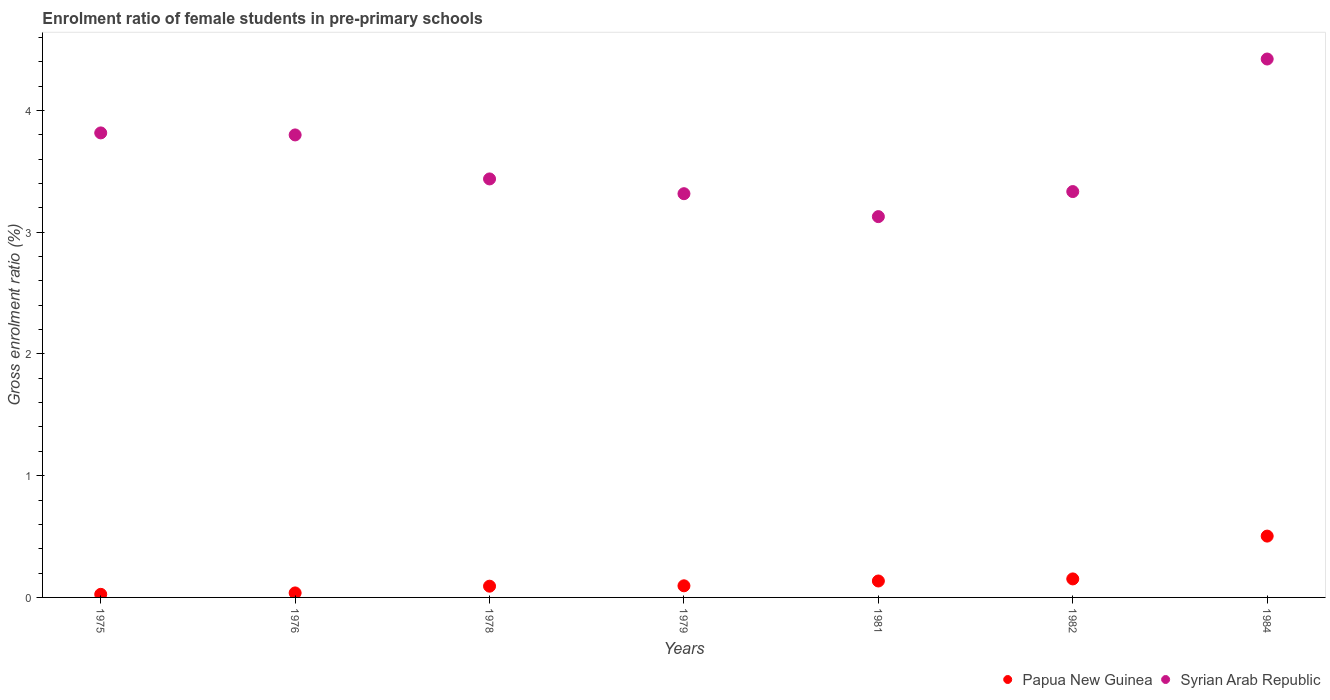How many different coloured dotlines are there?
Your response must be concise. 2. What is the enrolment ratio of female students in pre-primary schools in Syrian Arab Republic in 1982?
Your answer should be very brief. 3.33. Across all years, what is the maximum enrolment ratio of female students in pre-primary schools in Papua New Guinea?
Your answer should be compact. 0.5. Across all years, what is the minimum enrolment ratio of female students in pre-primary schools in Papua New Guinea?
Offer a very short reply. 0.03. In which year was the enrolment ratio of female students in pre-primary schools in Papua New Guinea maximum?
Offer a very short reply. 1984. In which year was the enrolment ratio of female students in pre-primary schools in Papua New Guinea minimum?
Give a very brief answer. 1975. What is the total enrolment ratio of female students in pre-primary schools in Papua New Guinea in the graph?
Provide a short and direct response. 1.04. What is the difference between the enrolment ratio of female students in pre-primary schools in Syrian Arab Republic in 1975 and that in 1982?
Your answer should be compact. 0.48. What is the difference between the enrolment ratio of female students in pre-primary schools in Papua New Guinea in 1984 and the enrolment ratio of female students in pre-primary schools in Syrian Arab Republic in 1975?
Ensure brevity in your answer.  -3.31. What is the average enrolment ratio of female students in pre-primary schools in Syrian Arab Republic per year?
Your answer should be very brief. 3.61. In the year 1978, what is the difference between the enrolment ratio of female students in pre-primary schools in Syrian Arab Republic and enrolment ratio of female students in pre-primary schools in Papua New Guinea?
Give a very brief answer. 3.35. In how many years, is the enrolment ratio of female students in pre-primary schools in Papua New Guinea greater than 1 %?
Your answer should be compact. 0. What is the ratio of the enrolment ratio of female students in pre-primary schools in Syrian Arab Republic in 1975 to that in 1981?
Keep it short and to the point. 1.22. Is the enrolment ratio of female students in pre-primary schools in Papua New Guinea in 1978 less than that in 1982?
Provide a short and direct response. Yes. What is the difference between the highest and the second highest enrolment ratio of female students in pre-primary schools in Papua New Guinea?
Make the answer very short. 0.35. What is the difference between the highest and the lowest enrolment ratio of female students in pre-primary schools in Papua New Guinea?
Provide a short and direct response. 0.48. In how many years, is the enrolment ratio of female students in pre-primary schools in Syrian Arab Republic greater than the average enrolment ratio of female students in pre-primary schools in Syrian Arab Republic taken over all years?
Your answer should be very brief. 3. Is the sum of the enrolment ratio of female students in pre-primary schools in Papua New Guinea in 1975 and 1978 greater than the maximum enrolment ratio of female students in pre-primary schools in Syrian Arab Republic across all years?
Provide a short and direct response. No. Is the enrolment ratio of female students in pre-primary schools in Syrian Arab Republic strictly greater than the enrolment ratio of female students in pre-primary schools in Papua New Guinea over the years?
Your answer should be compact. Yes. Is the enrolment ratio of female students in pre-primary schools in Papua New Guinea strictly less than the enrolment ratio of female students in pre-primary schools in Syrian Arab Republic over the years?
Provide a short and direct response. Yes. How many dotlines are there?
Provide a short and direct response. 2. Does the graph contain grids?
Provide a succinct answer. No. How many legend labels are there?
Make the answer very short. 2. What is the title of the graph?
Keep it short and to the point. Enrolment ratio of female students in pre-primary schools. What is the label or title of the X-axis?
Make the answer very short. Years. What is the label or title of the Y-axis?
Provide a succinct answer. Gross enrolment ratio (%). What is the Gross enrolment ratio (%) in Papua New Guinea in 1975?
Ensure brevity in your answer.  0.03. What is the Gross enrolment ratio (%) of Syrian Arab Republic in 1975?
Your response must be concise. 3.82. What is the Gross enrolment ratio (%) in Papua New Guinea in 1976?
Offer a terse response. 0.04. What is the Gross enrolment ratio (%) of Syrian Arab Republic in 1976?
Provide a short and direct response. 3.8. What is the Gross enrolment ratio (%) in Papua New Guinea in 1978?
Your response must be concise. 0.09. What is the Gross enrolment ratio (%) of Syrian Arab Republic in 1978?
Keep it short and to the point. 3.44. What is the Gross enrolment ratio (%) in Papua New Guinea in 1979?
Your response must be concise. 0.1. What is the Gross enrolment ratio (%) of Syrian Arab Republic in 1979?
Provide a succinct answer. 3.32. What is the Gross enrolment ratio (%) of Papua New Guinea in 1981?
Ensure brevity in your answer.  0.14. What is the Gross enrolment ratio (%) of Syrian Arab Republic in 1981?
Offer a very short reply. 3.13. What is the Gross enrolment ratio (%) in Papua New Guinea in 1982?
Offer a very short reply. 0.15. What is the Gross enrolment ratio (%) in Syrian Arab Republic in 1982?
Your answer should be compact. 3.33. What is the Gross enrolment ratio (%) of Papua New Guinea in 1984?
Provide a short and direct response. 0.5. What is the Gross enrolment ratio (%) of Syrian Arab Republic in 1984?
Your response must be concise. 4.42. Across all years, what is the maximum Gross enrolment ratio (%) of Papua New Guinea?
Offer a very short reply. 0.5. Across all years, what is the maximum Gross enrolment ratio (%) of Syrian Arab Republic?
Offer a very short reply. 4.42. Across all years, what is the minimum Gross enrolment ratio (%) of Papua New Guinea?
Your answer should be very brief. 0.03. Across all years, what is the minimum Gross enrolment ratio (%) in Syrian Arab Republic?
Provide a succinct answer. 3.13. What is the total Gross enrolment ratio (%) in Papua New Guinea in the graph?
Your answer should be very brief. 1.04. What is the total Gross enrolment ratio (%) in Syrian Arab Republic in the graph?
Provide a short and direct response. 25.25. What is the difference between the Gross enrolment ratio (%) in Papua New Guinea in 1975 and that in 1976?
Provide a succinct answer. -0.01. What is the difference between the Gross enrolment ratio (%) in Syrian Arab Republic in 1975 and that in 1976?
Make the answer very short. 0.02. What is the difference between the Gross enrolment ratio (%) of Papua New Guinea in 1975 and that in 1978?
Offer a very short reply. -0.07. What is the difference between the Gross enrolment ratio (%) in Syrian Arab Republic in 1975 and that in 1978?
Give a very brief answer. 0.38. What is the difference between the Gross enrolment ratio (%) in Papua New Guinea in 1975 and that in 1979?
Provide a short and direct response. -0.07. What is the difference between the Gross enrolment ratio (%) of Syrian Arab Republic in 1975 and that in 1979?
Offer a terse response. 0.5. What is the difference between the Gross enrolment ratio (%) of Papua New Guinea in 1975 and that in 1981?
Offer a terse response. -0.11. What is the difference between the Gross enrolment ratio (%) in Syrian Arab Republic in 1975 and that in 1981?
Provide a short and direct response. 0.69. What is the difference between the Gross enrolment ratio (%) in Papua New Guinea in 1975 and that in 1982?
Provide a succinct answer. -0.13. What is the difference between the Gross enrolment ratio (%) in Syrian Arab Republic in 1975 and that in 1982?
Your response must be concise. 0.48. What is the difference between the Gross enrolment ratio (%) in Papua New Guinea in 1975 and that in 1984?
Your response must be concise. -0.48. What is the difference between the Gross enrolment ratio (%) of Syrian Arab Republic in 1975 and that in 1984?
Ensure brevity in your answer.  -0.61. What is the difference between the Gross enrolment ratio (%) in Papua New Guinea in 1976 and that in 1978?
Provide a short and direct response. -0.06. What is the difference between the Gross enrolment ratio (%) of Syrian Arab Republic in 1976 and that in 1978?
Provide a succinct answer. 0.36. What is the difference between the Gross enrolment ratio (%) in Papua New Guinea in 1976 and that in 1979?
Ensure brevity in your answer.  -0.06. What is the difference between the Gross enrolment ratio (%) in Syrian Arab Republic in 1976 and that in 1979?
Make the answer very short. 0.48. What is the difference between the Gross enrolment ratio (%) of Papua New Guinea in 1976 and that in 1981?
Ensure brevity in your answer.  -0.1. What is the difference between the Gross enrolment ratio (%) of Syrian Arab Republic in 1976 and that in 1981?
Keep it short and to the point. 0.67. What is the difference between the Gross enrolment ratio (%) of Papua New Guinea in 1976 and that in 1982?
Offer a very short reply. -0.12. What is the difference between the Gross enrolment ratio (%) in Syrian Arab Republic in 1976 and that in 1982?
Keep it short and to the point. 0.47. What is the difference between the Gross enrolment ratio (%) of Papua New Guinea in 1976 and that in 1984?
Your response must be concise. -0.47. What is the difference between the Gross enrolment ratio (%) of Syrian Arab Republic in 1976 and that in 1984?
Provide a succinct answer. -0.62. What is the difference between the Gross enrolment ratio (%) in Papua New Guinea in 1978 and that in 1979?
Your answer should be very brief. -0. What is the difference between the Gross enrolment ratio (%) in Syrian Arab Republic in 1978 and that in 1979?
Ensure brevity in your answer.  0.12. What is the difference between the Gross enrolment ratio (%) of Papua New Guinea in 1978 and that in 1981?
Make the answer very short. -0.04. What is the difference between the Gross enrolment ratio (%) of Syrian Arab Republic in 1978 and that in 1981?
Provide a succinct answer. 0.31. What is the difference between the Gross enrolment ratio (%) of Papua New Guinea in 1978 and that in 1982?
Your answer should be very brief. -0.06. What is the difference between the Gross enrolment ratio (%) of Syrian Arab Republic in 1978 and that in 1982?
Ensure brevity in your answer.  0.1. What is the difference between the Gross enrolment ratio (%) in Papua New Guinea in 1978 and that in 1984?
Keep it short and to the point. -0.41. What is the difference between the Gross enrolment ratio (%) of Syrian Arab Republic in 1978 and that in 1984?
Your answer should be very brief. -0.98. What is the difference between the Gross enrolment ratio (%) of Papua New Guinea in 1979 and that in 1981?
Give a very brief answer. -0.04. What is the difference between the Gross enrolment ratio (%) of Syrian Arab Republic in 1979 and that in 1981?
Give a very brief answer. 0.19. What is the difference between the Gross enrolment ratio (%) in Papua New Guinea in 1979 and that in 1982?
Give a very brief answer. -0.06. What is the difference between the Gross enrolment ratio (%) of Syrian Arab Republic in 1979 and that in 1982?
Offer a terse response. -0.02. What is the difference between the Gross enrolment ratio (%) of Papua New Guinea in 1979 and that in 1984?
Your answer should be very brief. -0.41. What is the difference between the Gross enrolment ratio (%) of Syrian Arab Republic in 1979 and that in 1984?
Give a very brief answer. -1.11. What is the difference between the Gross enrolment ratio (%) in Papua New Guinea in 1981 and that in 1982?
Keep it short and to the point. -0.02. What is the difference between the Gross enrolment ratio (%) in Syrian Arab Republic in 1981 and that in 1982?
Your response must be concise. -0.21. What is the difference between the Gross enrolment ratio (%) of Papua New Guinea in 1981 and that in 1984?
Offer a very short reply. -0.37. What is the difference between the Gross enrolment ratio (%) in Syrian Arab Republic in 1981 and that in 1984?
Your answer should be compact. -1.29. What is the difference between the Gross enrolment ratio (%) in Papua New Guinea in 1982 and that in 1984?
Ensure brevity in your answer.  -0.35. What is the difference between the Gross enrolment ratio (%) of Syrian Arab Republic in 1982 and that in 1984?
Provide a short and direct response. -1.09. What is the difference between the Gross enrolment ratio (%) of Papua New Guinea in 1975 and the Gross enrolment ratio (%) of Syrian Arab Republic in 1976?
Ensure brevity in your answer.  -3.77. What is the difference between the Gross enrolment ratio (%) in Papua New Guinea in 1975 and the Gross enrolment ratio (%) in Syrian Arab Republic in 1978?
Offer a very short reply. -3.41. What is the difference between the Gross enrolment ratio (%) in Papua New Guinea in 1975 and the Gross enrolment ratio (%) in Syrian Arab Republic in 1979?
Offer a very short reply. -3.29. What is the difference between the Gross enrolment ratio (%) in Papua New Guinea in 1975 and the Gross enrolment ratio (%) in Syrian Arab Republic in 1981?
Provide a succinct answer. -3.1. What is the difference between the Gross enrolment ratio (%) of Papua New Guinea in 1975 and the Gross enrolment ratio (%) of Syrian Arab Republic in 1982?
Provide a succinct answer. -3.31. What is the difference between the Gross enrolment ratio (%) of Papua New Guinea in 1975 and the Gross enrolment ratio (%) of Syrian Arab Republic in 1984?
Offer a terse response. -4.4. What is the difference between the Gross enrolment ratio (%) in Papua New Guinea in 1976 and the Gross enrolment ratio (%) in Syrian Arab Republic in 1978?
Provide a short and direct response. -3.4. What is the difference between the Gross enrolment ratio (%) of Papua New Guinea in 1976 and the Gross enrolment ratio (%) of Syrian Arab Republic in 1979?
Your answer should be very brief. -3.28. What is the difference between the Gross enrolment ratio (%) of Papua New Guinea in 1976 and the Gross enrolment ratio (%) of Syrian Arab Republic in 1981?
Give a very brief answer. -3.09. What is the difference between the Gross enrolment ratio (%) of Papua New Guinea in 1976 and the Gross enrolment ratio (%) of Syrian Arab Republic in 1982?
Your answer should be very brief. -3.3. What is the difference between the Gross enrolment ratio (%) of Papua New Guinea in 1976 and the Gross enrolment ratio (%) of Syrian Arab Republic in 1984?
Offer a very short reply. -4.39. What is the difference between the Gross enrolment ratio (%) in Papua New Guinea in 1978 and the Gross enrolment ratio (%) in Syrian Arab Republic in 1979?
Offer a terse response. -3.22. What is the difference between the Gross enrolment ratio (%) of Papua New Guinea in 1978 and the Gross enrolment ratio (%) of Syrian Arab Republic in 1981?
Provide a short and direct response. -3.04. What is the difference between the Gross enrolment ratio (%) of Papua New Guinea in 1978 and the Gross enrolment ratio (%) of Syrian Arab Republic in 1982?
Provide a short and direct response. -3.24. What is the difference between the Gross enrolment ratio (%) of Papua New Guinea in 1978 and the Gross enrolment ratio (%) of Syrian Arab Republic in 1984?
Keep it short and to the point. -4.33. What is the difference between the Gross enrolment ratio (%) of Papua New Guinea in 1979 and the Gross enrolment ratio (%) of Syrian Arab Republic in 1981?
Provide a succinct answer. -3.03. What is the difference between the Gross enrolment ratio (%) in Papua New Guinea in 1979 and the Gross enrolment ratio (%) in Syrian Arab Republic in 1982?
Your answer should be very brief. -3.24. What is the difference between the Gross enrolment ratio (%) in Papua New Guinea in 1979 and the Gross enrolment ratio (%) in Syrian Arab Republic in 1984?
Provide a succinct answer. -4.33. What is the difference between the Gross enrolment ratio (%) of Papua New Guinea in 1981 and the Gross enrolment ratio (%) of Syrian Arab Republic in 1982?
Offer a terse response. -3.2. What is the difference between the Gross enrolment ratio (%) in Papua New Guinea in 1981 and the Gross enrolment ratio (%) in Syrian Arab Republic in 1984?
Give a very brief answer. -4.29. What is the difference between the Gross enrolment ratio (%) of Papua New Guinea in 1982 and the Gross enrolment ratio (%) of Syrian Arab Republic in 1984?
Ensure brevity in your answer.  -4.27. What is the average Gross enrolment ratio (%) in Papua New Guinea per year?
Make the answer very short. 0.15. What is the average Gross enrolment ratio (%) in Syrian Arab Republic per year?
Give a very brief answer. 3.61. In the year 1975, what is the difference between the Gross enrolment ratio (%) of Papua New Guinea and Gross enrolment ratio (%) of Syrian Arab Republic?
Your answer should be compact. -3.79. In the year 1976, what is the difference between the Gross enrolment ratio (%) of Papua New Guinea and Gross enrolment ratio (%) of Syrian Arab Republic?
Your response must be concise. -3.76. In the year 1978, what is the difference between the Gross enrolment ratio (%) of Papua New Guinea and Gross enrolment ratio (%) of Syrian Arab Republic?
Ensure brevity in your answer.  -3.35. In the year 1979, what is the difference between the Gross enrolment ratio (%) in Papua New Guinea and Gross enrolment ratio (%) in Syrian Arab Republic?
Make the answer very short. -3.22. In the year 1981, what is the difference between the Gross enrolment ratio (%) of Papua New Guinea and Gross enrolment ratio (%) of Syrian Arab Republic?
Your response must be concise. -2.99. In the year 1982, what is the difference between the Gross enrolment ratio (%) in Papua New Guinea and Gross enrolment ratio (%) in Syrian Arab Republic?
Offer a very short reply. -3.18. In the year 1984, what is the difference between the Gross enrolment ratio (%) of Papua New Guinea and Gross enrolment ratio (%) of Syrian Arab Republic?
Your answer should be very brief. -3.92. What is the ratio of the Gross enrolment ratio (%) in Papua New Guinea in 1975 to that in 1976?
Provide a short and direct response. 0.69. What is the ratio of the Gross enrolment ratio (%) in Papua New Guinea in 1975 to that in 1978?
Your answer should be very brief. 0.28. What is the ratio of the Gross enrolment ratio (%) of Syrian Arab Republic in 1975 to that in 1978?
Ensure brevity in your answer.  1.11. What is the ratio of the Gross enrolment ratio (%) in Papua New Guinea in 1975 to that in 1979?
Offer a terse response. 0.27. What is the ratio of the Gross enrolment ratio (%) of Syrian Arab Republic in 1975 to that in 1979?
Offer a very short reply. 1.15. What is the ratio of the Gross enrolment ratio (%) in Papua New Guinea in 1975 to that in 1981?
Ensure brevity in your answer.  0.19. What is the ratio of the Gross enrolment ratio (%) of Syrian Arab Republic in 1975 to that in 1981?
Your response must be concise. 1.22. What is the ratio of the Gross enrolment ratio (%) in Papua New Guinea in 1975 to that in 1982?
Give a very brief answer. 0.17. What is the ratio of the Gross enrolment ratio (%) of Syrian Arab Republic in 1975 to that in 1982?
Make the answer very short. 1.14. What is the ratio of the Gross enrolment ratio (%) of Papua New Guinea in 1975 to that in 1984?
Offer a very short reply. 0.05. What is the ratio of the Gross enrolment ratio (%) of Syrian Arab Republic in 1975 to that in 1984?
Provide a short and direct response. 0.86. What is the ratio of the Gross enrolment ratio (%) of Papua New Guinea in 1976 to that in 1978?
Offer a very short reply. 0.4. What is the ratio of the Gross enrolment ratio (%) of Syrian Arab Republic in 1976 to that in 1978?
Provide a short and direct response. 1.11. What is the ratio of the Gross enrolment ratio (%) in Papua New Guinea in 1976 to that in 1979?
Provide a short and direct response. 0.39. What is the ratio of the Gross enrolment ratio (%) of Syrian Arab Republic in 1976 to that in 1979?
Your response must be concise. 1.15. What is the ratio of the Gross enrolment ratio (%) in Papua New Guinea in 1976 to that in 1981?
Provide a succinct answer. 0.27. What is the ratio of the Gross enrolment ratio (%) of Syrian Arab Republic in 1976 to that in 1981?
Your answer should be very brief. 1.21. What is the ratio of the Gross enrolment ratio (%) in Papua New Guinea in 1976 to that in 1982?
Make the answer very short. 0.24. What is the ratio of the Gross enrolment ratio (%) of Syrian Arab Republic in 1976 to that in 1982?
Your answer should be compact. 1.14. What is the ratio of the Gross enrolment ratio (%) in Papua New Guinea in 1976 to that in 1984?
Provide a short and direct response. 0.07. What is the ratio of the Gross enrolment ratio (%) in Syrian Arab Republic in 1976 to that in 1984?
Offer a very short reply. 0.86. What is the ratio of the Gross enrolment ratio (%) of Papua New Guinea in 1978 to that in 1979?
Keep it short and to the point. 0.97. What is the ratio of the Gross enrolment ratio (%) of Syrian Arab Republic in 1978 to that in 1979?
Your response must be concise. 1.04. What is the ratio of the Gross enrolment ratio (%) of Papua New Guinea in 1978 to that in 1981?
Provide a short and direct response. 0.68. What is the ratio of the Gross enrolment ratio (%) in Syrian Arab Republic in 1978 to that in 1981?
Make the answer very short. 1.1. What is the ratio of the Gross enrolment ratio (%) in Papua New Guinea in 1978 to that in 1982?
Offer a very short reply. 0.61. What is the ratio of the Gross enrolment ratio (%) in Syrian Arab Republic in 1978 to that in 1982?
Provide a short and direct response. 1.03. What is the ratio of the Gross enrolment ratio (%) in Papua New Guinea in 1978 to that in 1984?
Ensure brevity in your answer.  0.18. What is the ratio of the Gross enrolment ratio (%) of Syrian Arab Republic in 1978 to that in 1984?
Make the answer very short. 0.78. What is the ratio of the Gross enrolment ratio (%) in Papua New Guinea in 1979 to that in 1981?
Give a very brief answer. 0.71. What is the ratio of the Gross enrolment ratio (%) of Syrian Arab Republic in 1979 to that in 1981?
Your response must be concise. 1.06. What is the ratio of the Gross enrolment ratio (%) in Papua New Guinea in 1979 to that in 1982?
Keep it short and to the point. 0.63. What is the ratio of the Gross enrolment ratio (%) in Papua New Guinea in 1979 to that in 1984?
Your response must be concise. 0.19. What is the ratio of the Gross enrolment ratio (%) of Syrian Arab Republic in 1979 to that in 1984?
Your response must be concise. 0.75. What is the ratio of the Gross enrolment ratio (%) of Papua New Guinea in 1981 to that in 1982?
Offer a terse response. 0.89. What is the ratio of the Gross enrolment ratio (%) of Syrian Arab Republic in 1981 to that in 1982?
Keep it short and to the point. 0.94. What is the ratio of the Gross enrolment ratio (%) of Papua New Guinea in 1981 to that in 1984?
Your response must be concise. 0.27. What is the ratio of the Gross enrolment ratio (%) of Syrian Arab Republic in 1981 to that in 1984?
Your answer should be very brief. 0.71. What is the ratio of the Gross enrolment ratio (%) in Papua New Guinea in 1982 to that in 1984?
Provide a short and direct response. 0.3. What is the ratio of the Gross enrolment ratio (%) in Syrian Arab Republic in 1982 to that in 1984?
Your answer should be very brief. 0.75. What is the difference between the highest and the second highest Gross enrolment ratio (%) of Papua New Guinea?
Your answer should be very brief. 0.35. What is the difference between the highest and the second highest Gross enrolment ratio (%) of Syrian Arab Republic?
Provide a succinct answer. 0.61. What is the difference between the highest and the lowest Gross enrolment ratio (%) of Papua New Guinea?
Your response must be concise. 0.48. What is the difference between the highest and the lowest Gross enrolment ratio (%) of Syrian Arab Republic?
Give a very brief answer. 1.29. 